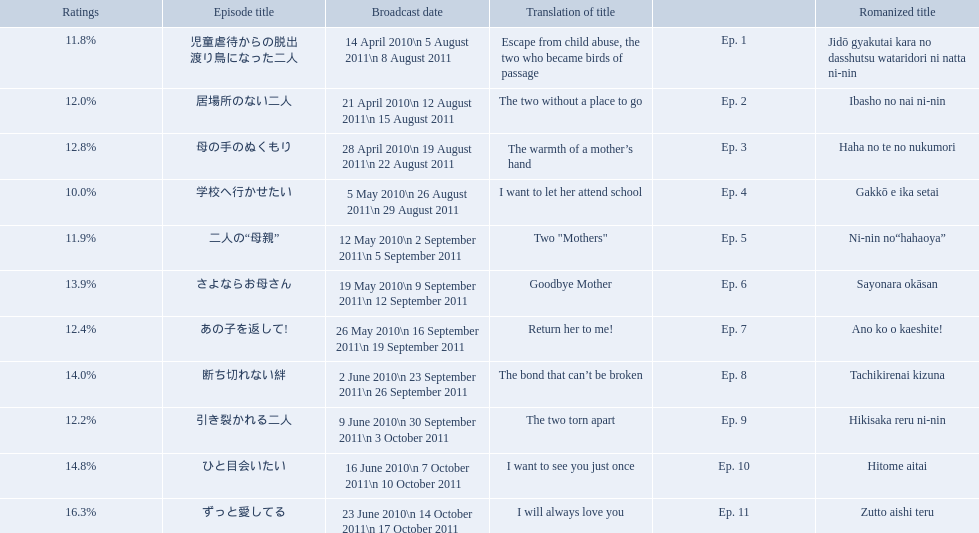What are all of the episode numbers? Ep. 1, Ep. 2, Ep. 3, Ep. 4, Ep. 5, Ep. 6, Ep. 7, Ep. 8, Ep. 9, Ep. 10, Ep. 11. And their titles? 児童虐待からの脱出 渡り鳥になった二人, 居場所のない二人, 母の手のぬくもり, 学校へ行かせたい, 二人の“母親”, さよならお母さん, あの子を返して!, 断ち切れない絆, 引き裂かれる二人, ひと目会いたい, ずっと愛してる. What about their translated names? Escape from child abuse, the two who became birds of passage, The two without a place to go, The warmth of a mother’s hand, I want to let her attend school, Two "Mothers", Goodbye Mother, Return her to me!, The bond that can’t be broken, The two torn apart, I want to see you just once, I will always love you. Which episode number's title translated to i want to let her attend school? Ep. 4. What are all the episodes? Ep. 1, Ep. 2, Ep. 3, Ep. 4, Ep. 5, Ep. 6, Ep. 7, Ep. 8, Ep. 9, Ep. 10, Ep. 11. Of these, which ones have a rating of 14%? Ep. 8, Ep. 10. Of these, which one is not ep. 10? Ep. 8. 